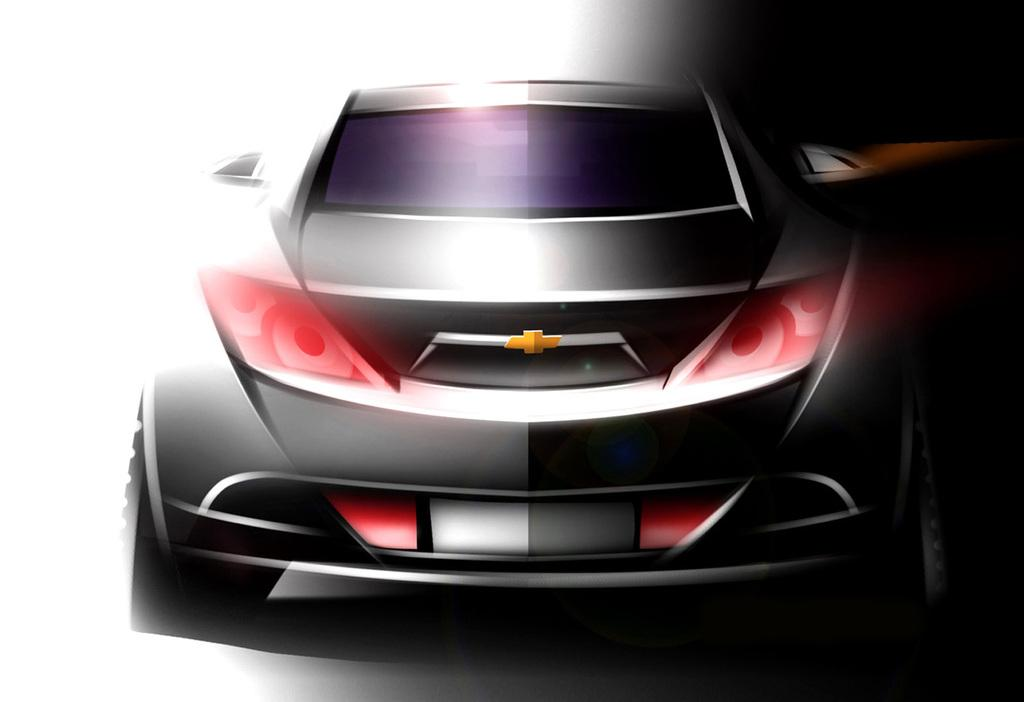What is the main subject of the image? There is a depiction of a car in the image. Can you describe the color scheme of the image? There is black color on the right side of the image and white color on the left side of the image. Where is the rake located in the image? There is no rake present in the image. What type of chair can be seen in the image? There is no chair present in the image. 